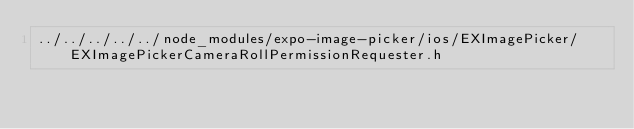Convert code to text. <code><loc_0><loc_0><loc_500><loc_500><_C_>../../../../../node_modules/expo-image-picker/ios/EXImagePicker/EXImagePickerCameraRollPermissionRequester.h</code> 